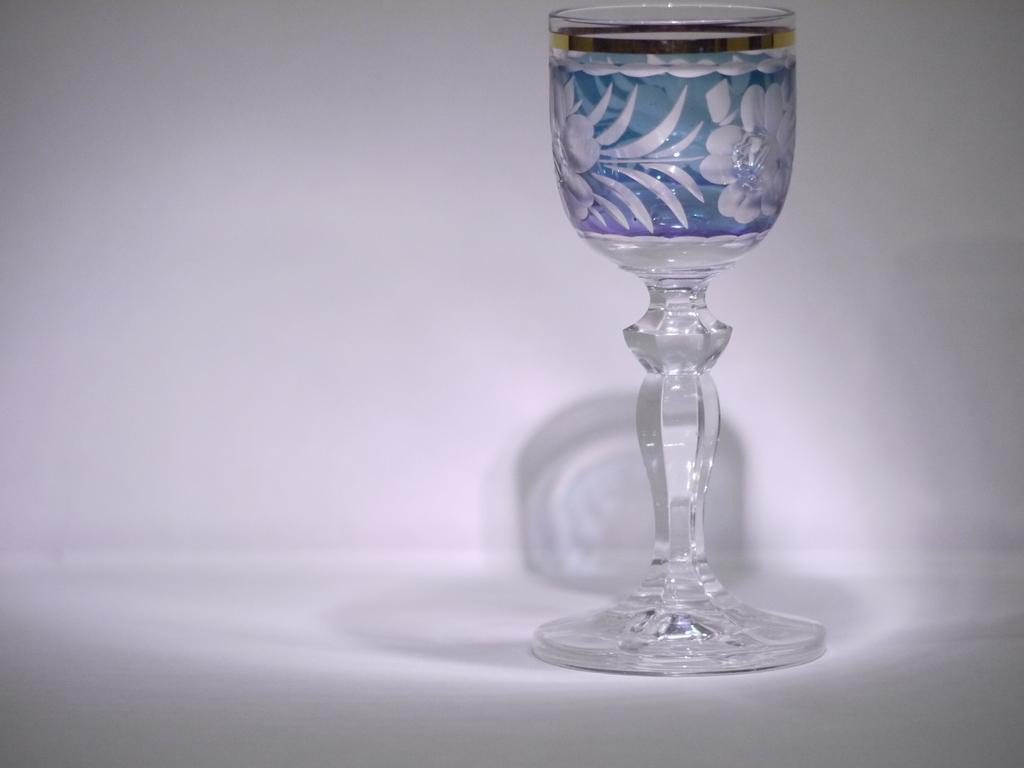In one or two sentences, can you explain what this image depicts? In this image we can see a glass with some design on it, the background is in white color and we can see the shadow of the glass on it. 